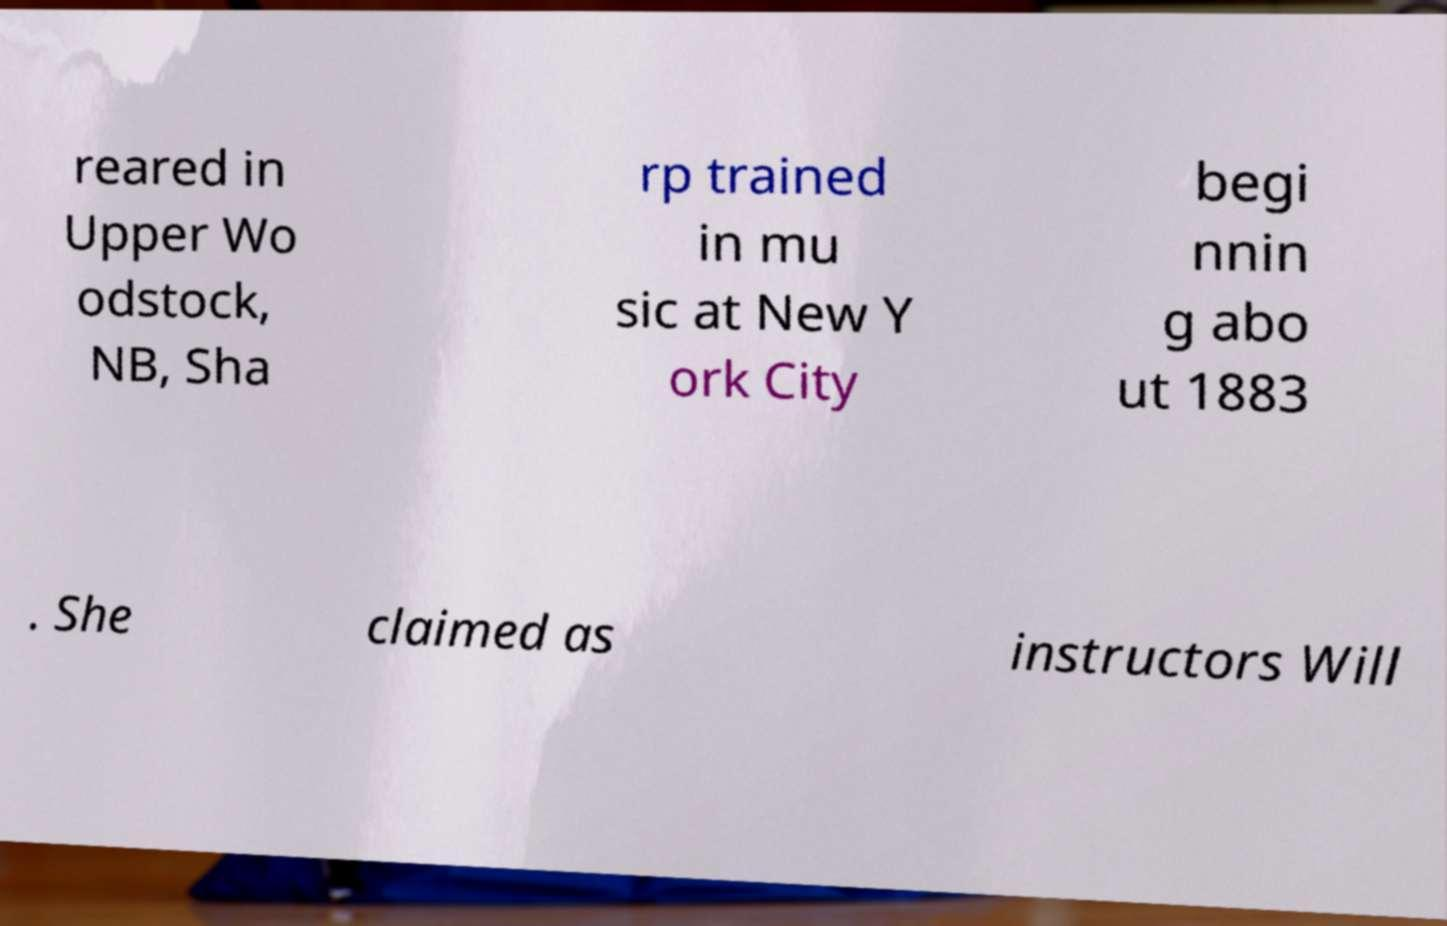Please identify and transcribe the text found in this image. reared in Upper Wo odstock, NB, Sha rp trained in mu sic at New Y ork City begi nnin g abo ut 1883 . She claimed as instructors Will 